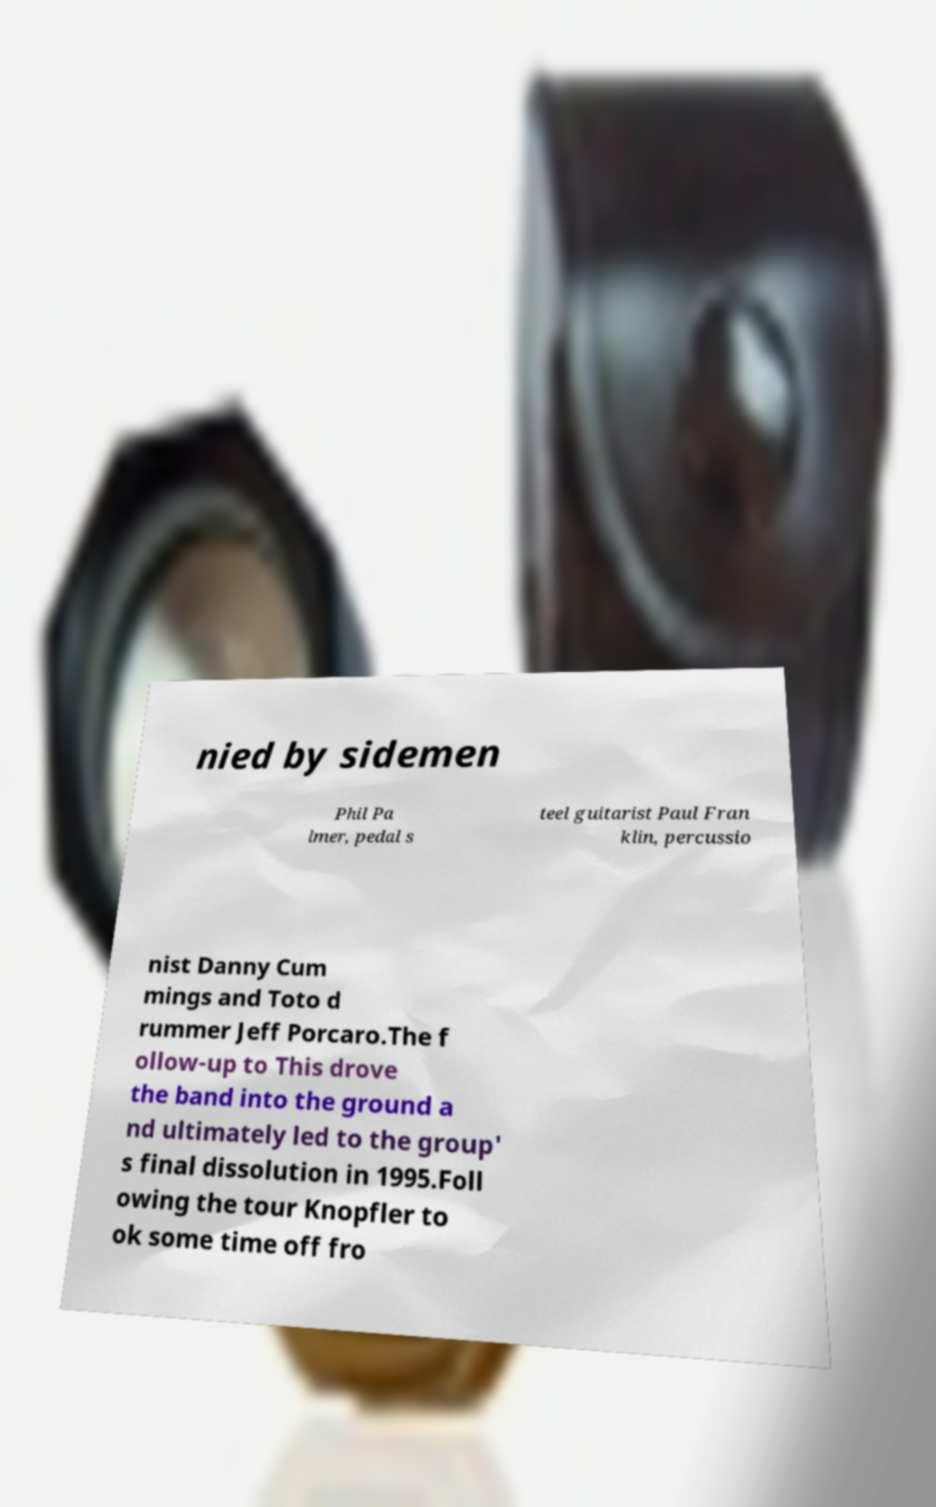Please identify and transcribe the text found in this image. nied by sidemen Phil Pa lmer, pedal s teel guitarist Paul Fran klin, percussio nist Danny Cum mings and Toto d rummer Jeff Porcaro.The f ollow-up to This drove the band into the ground a nd ultimately led to the group' s final dissolution in 1995.Foll owing the tour Knopfler to ok some time off fro 